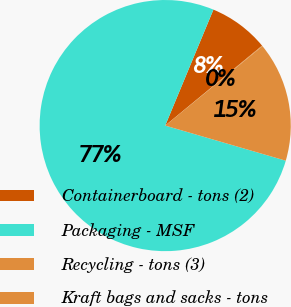Convert chart. <chart><loc_0><loc_0><loc_500><loc_500><pie_chart><fcel>Containerboard - tons (2)<fcel>Packaging - MSF<fcel>Recycling - tons (3)<fcel>Kraft bags and sacks - tons<nl><fcel>7.75%<fcel>76.76%<fcel>15.41%<fcel>0.08%<nl></chart> 